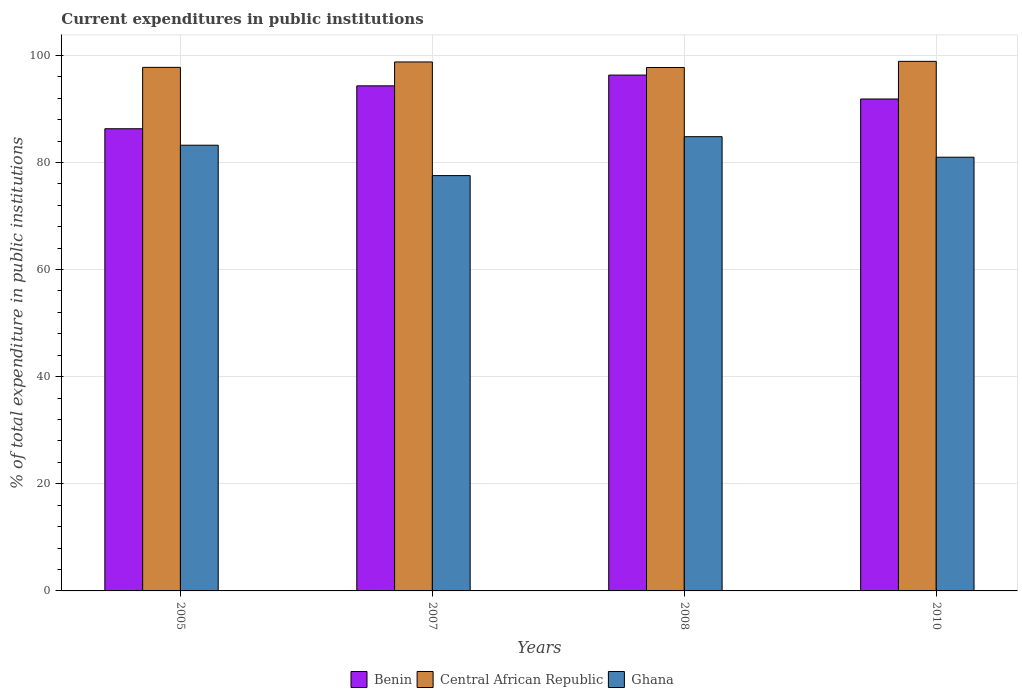How many different coloured bars are there?
Keep it short and to the point. 3. What is the label of the 1st group of bars from the left?
Offer a very short reply. 2005. What is the current expenditures in public institutions in Central African Republic in 2005?
Give a very brief answer. 97.75. Across all years, what is the maximum current expenditures in public institutions in Central African Republic?
Keep it short and to the point. 98.87. Across all years, what is the minimum current expenditures in public institutions in Central African Republic?
Offer a terse response. 97.73. In which year was the current expenditures in public institutions in Ghana maximum?
Ensure brevity in your answer.  2008. In which year was the current expenditures in public institutions in Benin minimum?
Ensure brevity in your answer.  2005. What is the total current expenditures in public institutions in Ghana in the graph?
Your answer should be very brief. 326.55. What is the difference between the current expenditures in public institutions in Benin in 2008 and that in 2010?
Ensure brevity in your answer.  4.46. What is the difference between the current expenditures in public institutions in Central African Republic in 2008 and the current expenditures in public institutions in Benin in 2005?
Offer a very short reply. 11.43. What is the average current expenditures in public institutions in Benin per year?
Your answer should be very brief. 92.19. In the year 2008, what is the difference between the current expenditures in public institutions in Central African Republic and current expenditures in public institutions in Ghana?
Your answer should be compact. 12.92. What is the ratio of the current expenditures in public institutions in Benin in 2007 to that in 2010?
Your response must be concise. 1.03. What is the difference between the highest and the second highest current expenditures in public institutions in Benin?
Make the answer very short. 2.01. What is the difference between the highest and the lowest current expenditures in public institutions in Ghana?
Provide a short and direct response. 7.27. What does the 2nd bar from the left in 2008 represents?
Your answer should be compact. Central African Republic. What does the 2nd bar from the right in 2007 represents?
Provide a short and direct response. Central African Republic. Are all the bars in the graph horizontal?
Your answer should be very brief. No. Are the values on the major ticks of Y-axis written in scientific E-notation?
Offer a terse response. No. Does the graph contain any zero values?
Your response must be concise. No. How many legend labels are there?
Give a very brief answer. 3. What is the title of the graph?
Offer a very short reply. Current expenditures in public institutions. Does "Saudi Arabia" appear as one of the legend labels in the graph?
Provide a short and direct response. No. What is the label or title of the Y-axis?
Your answer should be very brief. % of total expenditure in public institutions. What is the % of total expenditure in public institutions in Benin in 2005?
Your answer should be compact. 86.29. What is the % of total expenditure in public institutions in Central African Republic in 2005?
Ensure brevity in your answer.  97.75. What is the % of total expenditure in public institutions of Ghana in 2005?
Offer a very short reply. 83.22. What is the % of total expenditure in public institutions in Benin in 2007?
Offer a terse response. 94.3. What is the % of total expenditure in public institutions of Central African Republic in 2007?
Ensure brevity in your answer.  98.76. What is the % of total expenditure in public institutions of Ghana in 2007?
Your response must be concise. 77.54. What is the % of total expenditure in public institutions of Benin in 2008?
Give a very brief answer. 96.31. What is the % of total expenditure in public institutions in Central African Republic in 2008?
Make the answer very short. 97.73. What is the % of total expenditure in public institutions in Ghana in 2008?
Offer a very short reply. 84.81. What is the % of total expenditure in public institutions of Benin in 2010?
Your answer should be compact. 91.85. What is the % of total expenditure in public institutions of Central African Republic in 2010?
Provide a succinct answer. 98.87. What is the % of total expenditure in public institutions of Ghana in 2010?
Keep it short and to the point. 80.98. Across all years, what is the maximum % of total expenditure in public institutions in Benin?
Ensure brevity in your answer.  96.31. Across all years, what is the maximum % of total expenditure in public institutions in Central African Republic?
Provide a short and direct response. 98.87. Across all years, what is the maximum % of total expenditure in public institutions in Ghana?
Provide a short and direct response. 84.81. Across all years, what is the minimum % of total expenditure in public institutions in Benin?
Your response must be concise. 86.29. Across all years, what is the minimum % of total expenditure in public institutions in Central African Republic?
Ensure brevity in your answer.  97.73. Across all years, what is the minimum % of total expenditure in public institutions in Ghana?
Keep it short and to the point. 77.54. What is the total % of total expenditure in public institutions of Benin in the graph?
Ensure brevity in your answer.  368.75. What is the total % of total expenditure in public institutions in Central African Republic in the graph?
Provide a succinct answer. 393.12. What is the total % of total expenditure in public institutions of Ghana in the graph?
Provide a short and direct response. 326.55. What is the difference between the % of total expenditure in public institutions of Benin in 2005 and that in 2007?
Provide a short and direct response. -8.01. What is the difference between the % of total expenditure in public institutions of Central African Republic in 2005 and that in 2007?
Ensure brevity in your answer.  -1.01. What is the difference between the % of total expenditure in public institutions in Ghana in 2005 and that in 2007?
Provide a short and direct response. 5.68. What is the difference between the % of total expenditure in public institutions in Benin in 2005 and that in 2008?
Ensure brevity in your answer.  -10.02. What is the difference between the % of total expenditure in public institutions in Central African Republic in 2005 and that in 2008?
Your answer should be compact. 0.02. What is the difference between the % of total expenditure in public institutions in Ghana in 2005 and that in 2008?
Provide a short and direct response. -1.59. What is the difference between the % of total expenditure in public institutions of Benin in 2005 and that in 2010?
Ensure brevity in your answer.  -5.56. What is the difference between the % of total expenditure in public institutions of Central African Republic in 2005 and that in 2010?
Keep it short and to the point. -1.12. What is the difference between the % of total expenditure in public institutions in Ghana in 2005 and that in 2010?
Your answer should be very brief. 2.24. What is the difference between the % of total expenditure in public institutions in Benin in 2007 and that in 2008?
Ensure brevity in your answer.  -2.01. What is the difference between the % of total expenditure in public institutions of Central African Republic in 2007 and that in 2008?
Keep it short and to the point. 1.03. What is the difference between the % of total expenditure in public institutions of Ghana in 2007 and that in 2008?
Ensure brevity in your answer.  -7.27. What is the difference between the % of total expenditure in public institutions in Benin in 2007 and that in 2010?
Provide a short and direct response. 2.45. What is the difference between the % of total expenditure in public institutions in Central African Republic in 2007 and that in 2010?
Your response must be concise. -0.11. What is the difference between the % of total expenditure in public institutions in Ghana in 2007 and that in 2010?
Ensure brevity in your answer.  -3.43. What is the difference between the % of total expenditure in public institutions in Benin in 2008 and that in 2010?
Your response must be concise. 4.46. What is the difference between the % of total expenditure in public institutions of Central African Republic in 2008 and that in 2010?
Offer a very short reply. -1.15. What is the difference between the % of total expenditure in public institutions in Ghana in 2008 and that in 2010?
Offer a terse response. 3.83. What is the difference between the % of total expenditure in public institutions of Benin in 2005 and the % of total expenditure in public institutions of Central African Republic in 2007?
Make the answer very short. -12.47. What is the difference between the % of total expenditure in public institutions in Benin in 2005 and the % of total expenditure in public institutions in Ghana in 2007?
Your answer should be compact. 8.75. What is the difference between the % of total expenditure in public institutions in Central African Republic in 2005 and the % of total expenditure in public institutions in Ghana in 2007?
Make the answer very short. 20.21. What is the difference between the % of total expenditure in public institutions in Benin in 2005 and the % of total expenditure in public institutions in Central African Republic in 2008?
Your answer should be very brief. -11.43. What is the difference between the % of total expenditure in public institutions of Benin in 2005 and the % of total expenditure in public institutions of Ghana in 2008?
Your answer should be compact. 1.48. What is the difference between the % of total expenditure in public institutions of Central African Republic in 2005 and the % of total expenditure in public institutions of Ghana in 2008?
Give a very brief answer. 12.94. What is the difference between the % of total expenditure in public institutions of Benin in 2005 and the % of total expenditure in public institutions of Central African Republic in 2010?
Ensure brevity in your answer.  -12.58. What is the difference between the % of total expenditure in public institutions in Benin in 2005 and the % of total expenditure in public institutions in Ghana in 2010?
Your answer should be very brief. 5.32. What is the difference between the % of total expenditure in public institutions in Central African Republic in 2005 and the % of total expenditure in public institutions in Ghana in 2010?
Provide a short and direct response. 16.78. What is the difference between the % of total expenditure in public institutions in Benin in 2007 and the % of total expenditure in public institutions in Central African Republic in 2008?
Give a very brief answer. -3.43. What is the difference between the % of total expenditure in public institutions of Benin in 2007 and the % of total expenditure in public institutions of Ghana in 2008?
Keep it short and to the point. 9.49. What is the difference between the % of total expenditure in public institutions of Central African Republic in 2007 and the % of total expenditure in public institutions of Ghana in 2008?
Provide a succinct answer. 13.95. What is the difference between the % of total expenditure in public institutions in Benin in 2007 and the % of total expenditure in public institutions in Central African Republic in 2010?
Provide a succinct answer. -4.57. What is the difference between the % of total expenditure in public institutions in Benin in 2007 and the % of total expenditure in public institutions in Ghana in 2010?
Offer a terse response. 13.32. What is the difference between the % of total expenditure in public institutions of Central African Republic in 2007 and the % of total expenditure in public institutions of Ghana in 2010?
Your response must be concise. 17.78. What is the difference between the % of total expenditure in public institutions in Benin in 2008 and the % of total expenditure in public institutions in Central African Republic in 2010?
Make the answer very short. -2.57. What is the difference between the % of total expenditure in public institutions in Benin in 2008 and the % of total expenditure in public institutions in Ghana in 2010?
Provide a succinct answer. 15.33. What is the difference between the % of total expenditure in public institutions of Central African Republic in 2008 and the % of total expenditure in public institutions of Ghana in 2010?
Your response must be concise. 16.75. What is the average % of total expenditure in public institutions in Benin per year?
Your answer should be compact. 92.19. What is the average % of total expenditure in public institutions of Central African Republic per year?
Your response must be concise. 98.28. What is the average % of total expenditure in public institutions of Ghana per year?
Offer a very short reply. 81.64. In the year 2005, what is the difference between the % of total expenditure in public institutions in Benin and % of total expenditure in public institutions in Central African Republic?
Your answer should be compact. -11.46. In the year 2005, what is the difference between the % of total expenditure in public institutions of Benin and % of total expenditure in public institutions of Ghana?
Give a very brief answer. 3.07. In the year 2005, what is the difference between the % of total expenditure in public institutions in Central African Republic and % of total expenditure in public institutions in Ghana?
Provide a succinct answer. 14.53. In the year 2007, what is the difference between the % of total expenditure in public institutions of Benin and % of total expenditure in public institutions of Central African Republic?
Provide a succinct answer. -4.46. In the year 2007, what is the difference between the % of total expenditure in public institutions of Benin and % of total expenditure in public institutions of Ghana?
Your answer should be compact. 16.76. In the year 2007, what is the difference between the % of total expenditure in public institutions of Central African Republic and % of total expenditure in public institutions of Ghana?
Your answer should be very brief. 21.22. In the year 2008, what is the difference between the % of total expenditure in public institutions in Benin and % of total expenditure in public institutions in Central African Republic?
Ensure brevity in your answer.  -1.42. In the year 2008, what is the difference between the % of total expenditure in public institutions of Benin and % of total expenditure in public institutions of Ghana?
Ensure brevity in your answer.  11.5. In the year 2008, what is the difference between the % of total expenditure in public institutions of Central African Republic and % of total expenditure in public institutions of Ghana?
Offer a terse response. 12.92. In the year 2010, what is the difference between the % of total expenditure in public institutions of Benin and % of total expenditure in public institutions of Central African Republic?
Ensure brevity in your answer.  -7.03. In the year 2010, what is the difference between the % of total expenditure in public institutions of Benin and % of total expenditure in public institutions of Ghana?
Ensure brevity in your answer.  10.87. In the year 2010, what is the difference between the % of total expenditure in public institutions of Central African Republic and % of total expenditure in public institutions of Ghana?
Offer a terse response. 17.9. What is the ratio of the % of total expenditure in public institutions in Benin in 2005 to that in 2007?
Your response must be concise. 0.92. What is the ratio of the % of total expenditure in public institutions of Central African Republic in 2005 to that in 2007?
Provide a succinct answer. 0.99. What is the ratio of the % of total expenditure in public institutions in Ghana in 2005 to that in 2007?
Ensure brevity in your answer.  1.07. What is the ratio of the % of total expenditure in public institutions of Benin in 2005 to that in 2008?
Ensure brevity in your answer.  0.9. What is the ratio of the % of total expenditure in public institutions in Ghana in 2005 to that in 2008?
Ensure brevity in your answer.  0.98. What is the ratio of the % of total expenditure in public institutions of Benin in 2005 to that in 2010?
Your answer should be compact. 0.94. What is the ratio of the % of total expenditure in public institutions in Ghana in 2005 to that in 2010?
Your answer should be compact. 1.03. What is the ratio of the % of total expenditure in public institutions of Benin in 2007 to that in 2008?
Make the answer very short. 0.98. What is the ratio of the % of total expenditure in public institutions of Central African Republic in 2007 to that in 2008?
Give a very brief answer. 1.01. What is the ratio of the % of total expenditure in public institutions of Ghana in 2007 to that in 2008?
Provide a short and direct response. 0.91. What is the ratio of the % of total expenditure in public institutions in Benin in 2007 to that in 2010?
Make the answer very short. 1.03. What is the ratio of the % of total expenditure in public institutions in Central African Republic in 2007 to that in 2010?
Ensure brevity in your answer.  1. What is the ratio of the % of total expenditure in public institutions in Ghana in 2007 to that in 2010?
Your answer should be compact. 0.96. What is the ratio of the % of total expenditure in public institutions in Benin in 2008 to that in 2010?
Your answer should be compact. 1.05. What is the ratio of the % of total expenditure in public institutions in Central African Republic in 2008 to that in 2010?
Provide a short and direct response. 0.99. What is the ratio of the % of total expenditure in public institutions of Ghana in 2008 to that in 2010?
Your answer should be compact. 1.05. What is the difference between the highest and the second highest % of total expenditure in public institutions in Benin?
Make the answer very short. 2.01. What is the difference between the highest and the second highest % of total expenditure in public institutions in Central African Republic?
Make the answer very short. 0.11. What is the difference between the highest and the second highest % of total expenditure in public institutions of Ghana?
Offer a very short reply. 1.59. What is the difference between the highest and the lowest % of total expenditure in public institutions in Benin?
Make the answer very short. 10.02. What is the difference between the highest and the lowest % of total expenditure in public institutions of Central African Republic?
Your response must be concise. 1.15. What is the difference between the highest and the lowest % of total expenditure in public institutions in Ghana?
Provide a short and direct response. 7.27. 